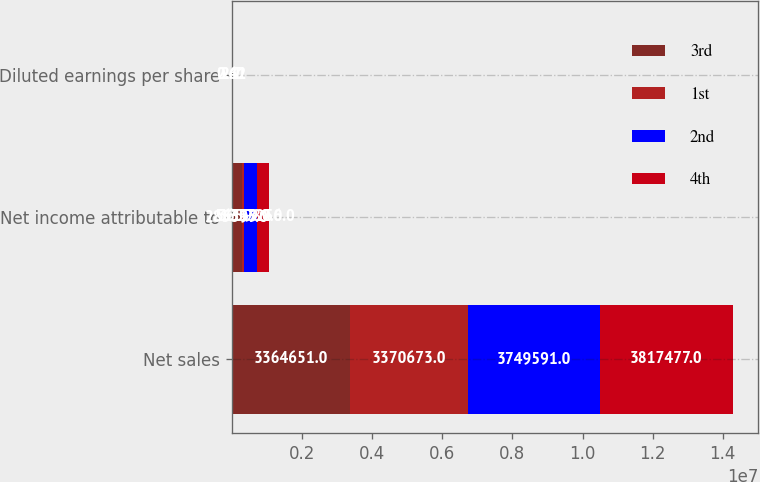Convert chart. <chart><loc_0><loc_0><loc_500><loc_500><stacked_bar_chart><ecel><fcel>Net sales<fcel>Net income attributable to<fcel>Diluted earnings per share<nl><fcel>3rd<fcel>3.36465e+06<fcel>285397<fcel>2.1<nl><fcel>1st<fcel>3.37067e+06<fcel>56159<fcel>0.41<nl><fcel>2nd<fcel>3.74959e+06<fcel>365989<fcel>2.7<nl><fcel>4th<fcel>3.81748e+06<fcel>353256<fcel>2.62<nl></chart> 